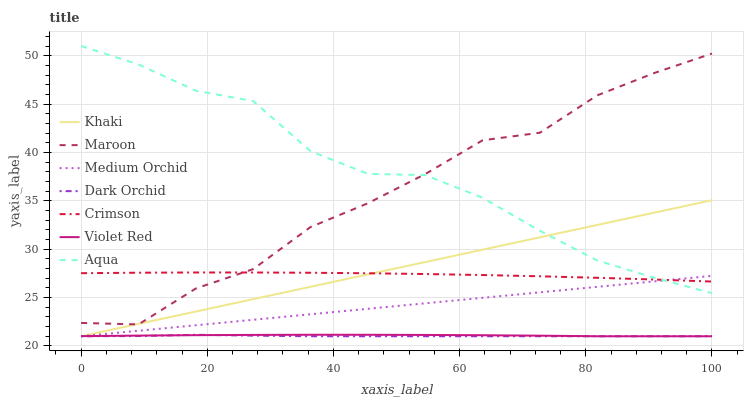Does Dark Orchid have the minimum area under the curve?
Answer yes or no. Yes. Does Aqua have the maximum area under the curve?
Answer yes or no. Yes. Does Khaki have the minimum area under the curve?
Answer yes or no. No. Does Khaki have the maximum area under the curve?
Answer yes or no. No. Is Medium Orchid the smoothest?
Answer yes or no. Yes. Is Maroon the roughest?
Answer yes or no. Yes. Is Khaki the smoothest?
Answer yes or no. No. Is Khaki the roughest?
Answer yes or no. No. Does Violet Red have the lowest value?
Answer yes or no. Yes. Does Aqua have the lowest value?
Answer yes or no. No. Does Aqua have the highest value?
Answer yes or no. Yes. Does Khaki have the highest value?
Answer yes or no. No. Is Dark Orchid less than Crimson?
Answer yes or no. Yes. Is Crimson greater than Violet Red?
Answer yes or no. Yes. Does Crimson intersect Medium Orchid?
Answer yes or no. Yes. Is Crimson less than Medium Orchid?
Answer yes or no. No. Is Crimson greater than Medium Orchid?
Answer yes or no. No. Does Dark Orchid intersect Crimson?
Answer yes or no. No. 